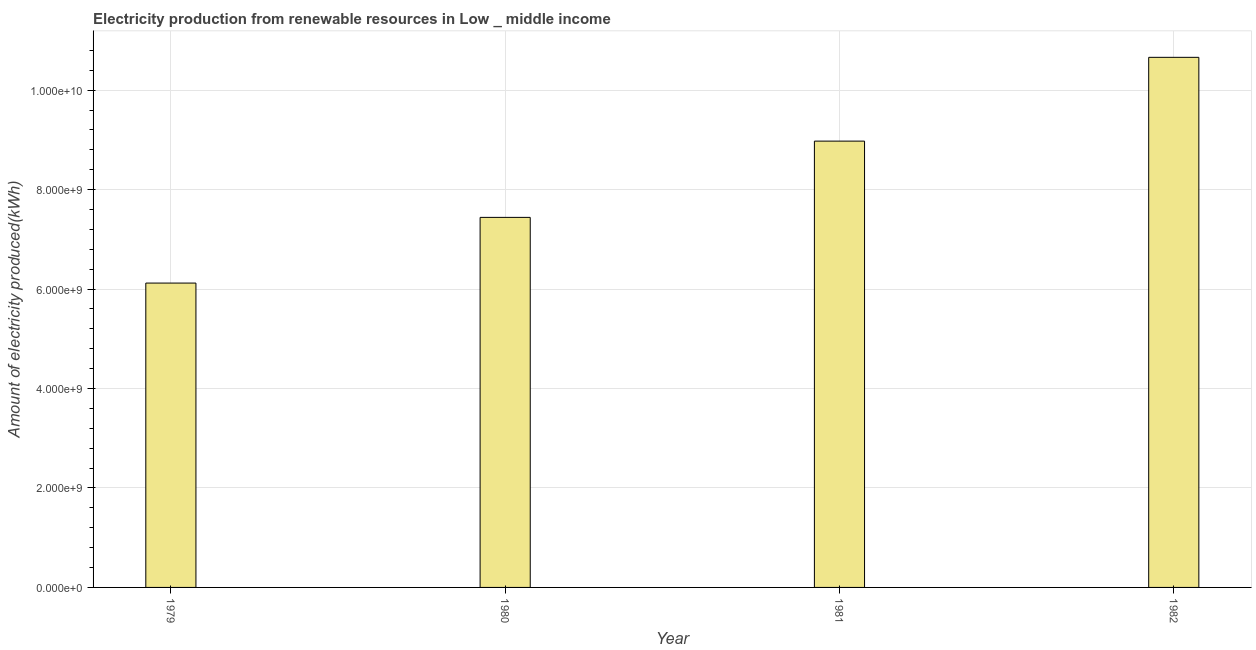Does the graph contain any zero values?
Provide a short and direct response. No. Does the graph contain grids?
Your answer should be compact. Yes. What is the title of the graph?
Give a very brief answer. Electricity production from renewable resources in Low _ middle income. What is the label or title of the Y-axis?
Ensure brevity in your answer.  Amount of electricity produced(kWh). What is the amount of electricity produced in 1981?
Provide a succinct answer. 8.98e+09. Across all years, what is the maximum amount of electricity produced?
Your response must be concise. 1.07e+1. Across all years, what is the minimum amount of electricity produced?
Your answer should be very brief. 6.12e+09. In which year was the amount of electricity produced minimum?
Provide a succinct answer. 1979. What is the sum of the amount of electricity produced?
Your answer should be very brief. 3.32e+1. What is the difference between the amount of electricity produced in 1979 and 1982?
Ensure brevity in your answer.  -4.54e+09. What is the average amount of electricity produced per year?
Provide a succinct answer. 8.30e+09. What is the median amount of electricity produced?
Your answer should be compact. 8.21e+09. In how many years, is the amount of electricity produced greater than 9200000000 kWh?
Offer a terse response. 1. Do a majority of the years between 1982 and 1981 (inclusive) have amount of electricity produced greater than 9200000000 kWh?
Ensure brevity in your answer.  No. What is the ratio of the amount of electricity produced in 1980 to that in 1981?
Make the answer very short. 0.83. Is the amount of electricity produced in 1979 less than that in 1982?
Offer a terse response. Yes. What is the difference between the highest and the second highest amount of electricity produced?
Make the answer very short. 1.68e+09. What is the difference between the highest and the lowest amount of electricity produced?
Give a very brief answer. 4.54e+09. In how many years, is the amount of electricity produced greater than the average amount of electricity produced taken over all years?
Offer a terse response. 2. How many years are there in the graph?
Offer a terse response. 4. What is the difference between two consecutive major ticks on the Y-axis?
Keep it short and to the point. 2.00e+09. Are the values on the major ticks of Y-axis written in scientific E-notation?
Provide a succinct answer. Yes. What is the Amount of electricity produced(kWh) in 1979?
Keep it short and to the point. 6.12e+09. What is the Amount of electricity produced(kWh) of 1980?
Give a very brief answer. 7.44e+09. What is the Amount of electricity produced(kWh) in 1981?
Offer a terse response. 8.98e+09. What is the Amount of electricity produced(kWh) in 1982?
Your answer should be very brief. 1.07e+1. What is the difference between the Amount of electricity produced(kWh) in 1979 and 1980?
Offer a very short reply. -1.32e+09. What is the difference between the Amount of electricity produced(kWh) in 1979 and 1981?
Provide a short and direct response. -2.86e+09. What is the difference between the Amount of electricity produced(kWh) in 1979 and 1982?
Provide a succinct answer. -4.54e+09. What is the difference between the Amount of electricity produced(kWh) in 1980 and 1981?
Your answer should be compact. -1.53e+09. What is the difference between the Amount of electricity produced(kWh) in 1980 and 1982?
Offer a terse response. -3.22e+09. What is the difference between the Amount of electricity produced(kWh) in 1981 and 1982?
Make the answer very short. -1.68e+09. What is the ratio of the Amount of electricity produced(kWh) in 1979 to that in 1980?
Make the answer very short. 0.82. What is the ratio of the Amount of electricity produced(kWh) in 1979 to that in 1981?
Keep it short and to the point. 0.68. What is the ratio of the Amount of electricity produced(kWh) in 1979 to that in 1982?
Your answer should be compact. 0.57. What is the ratio of the Amount of electricity produced(kWh) in 1980 to that in 1981?
Keep it short and to the point. 0.83. What is the ratio of the Amount of electricity produced(kWh) in 1980 to that in 1982?
Provide a succinct answer. 0.7. What is the ratio of the Amount of electricity produced(kWh) in 1981 to that in 1982?
Provide a succinct answer. 0.84. 